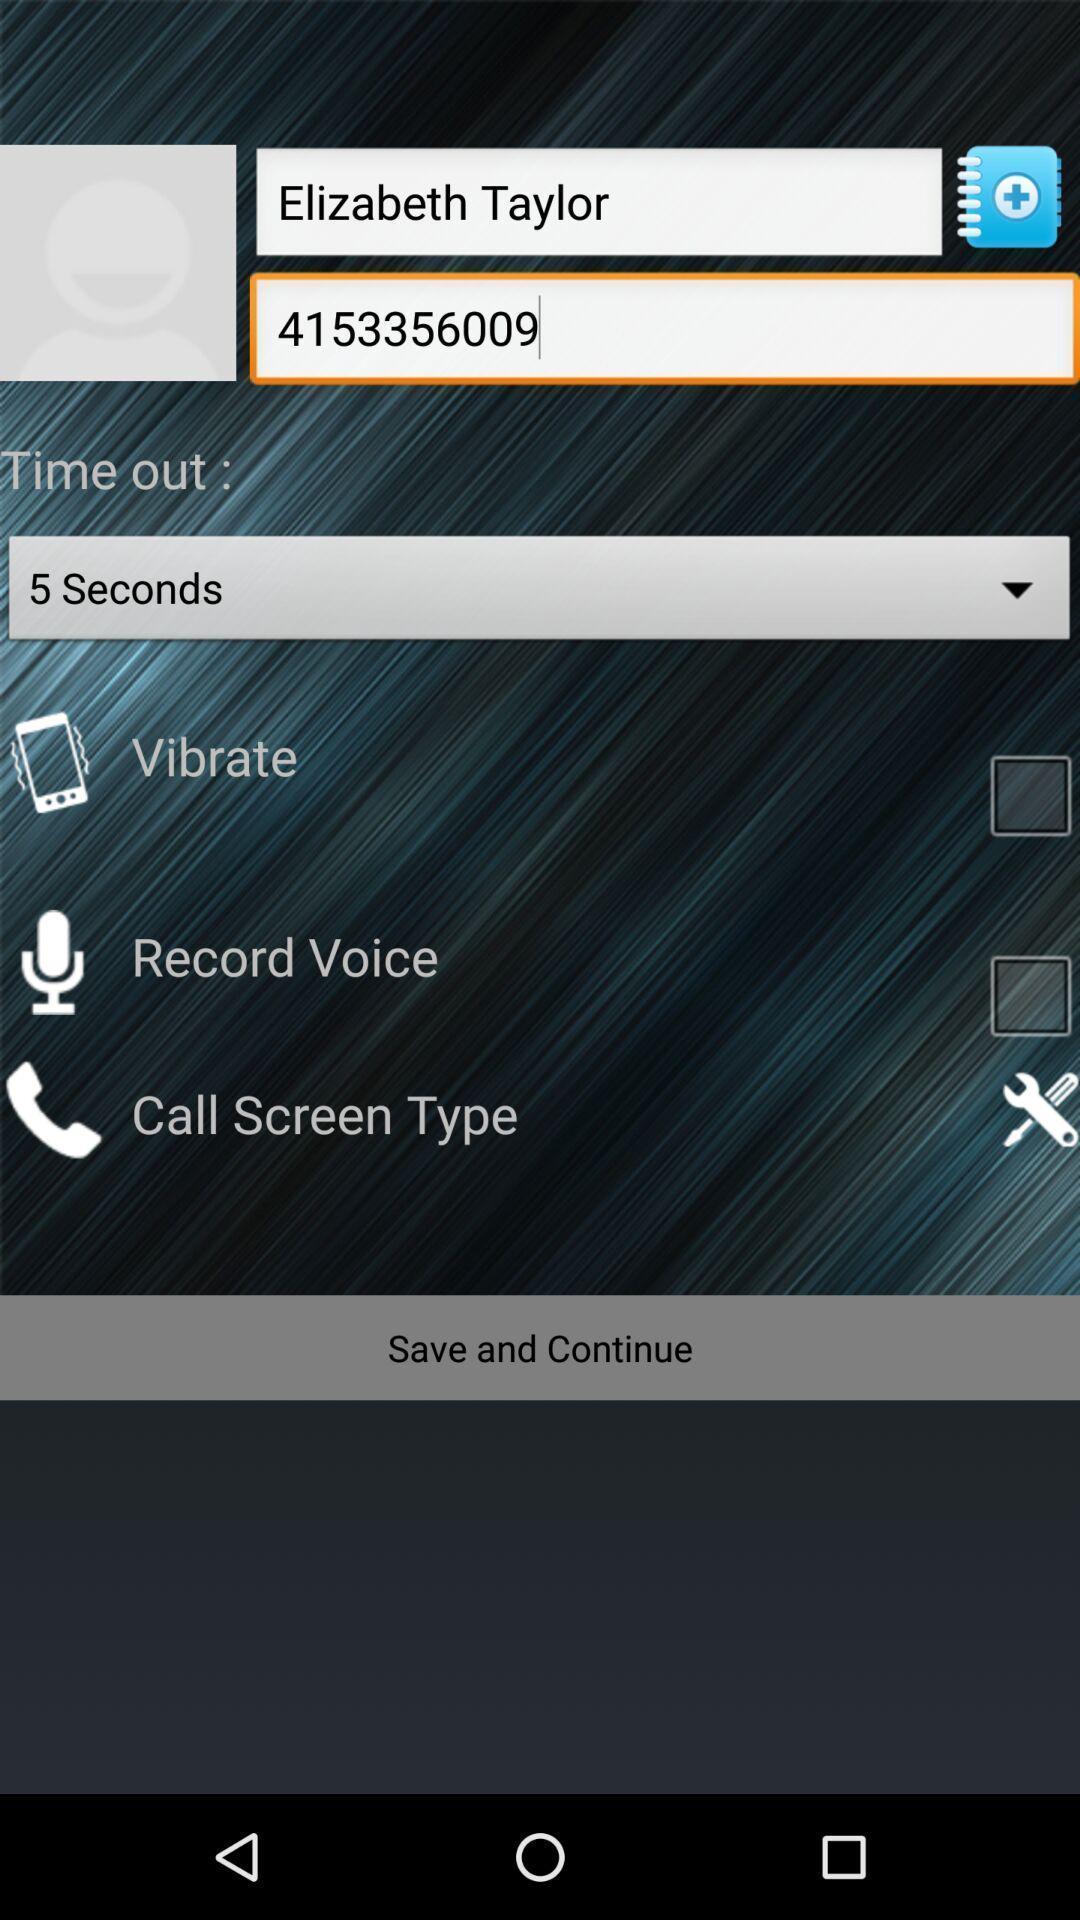Provide a detailed account of this screenshot. Screen displaying user information and multiple options in phonebook. 